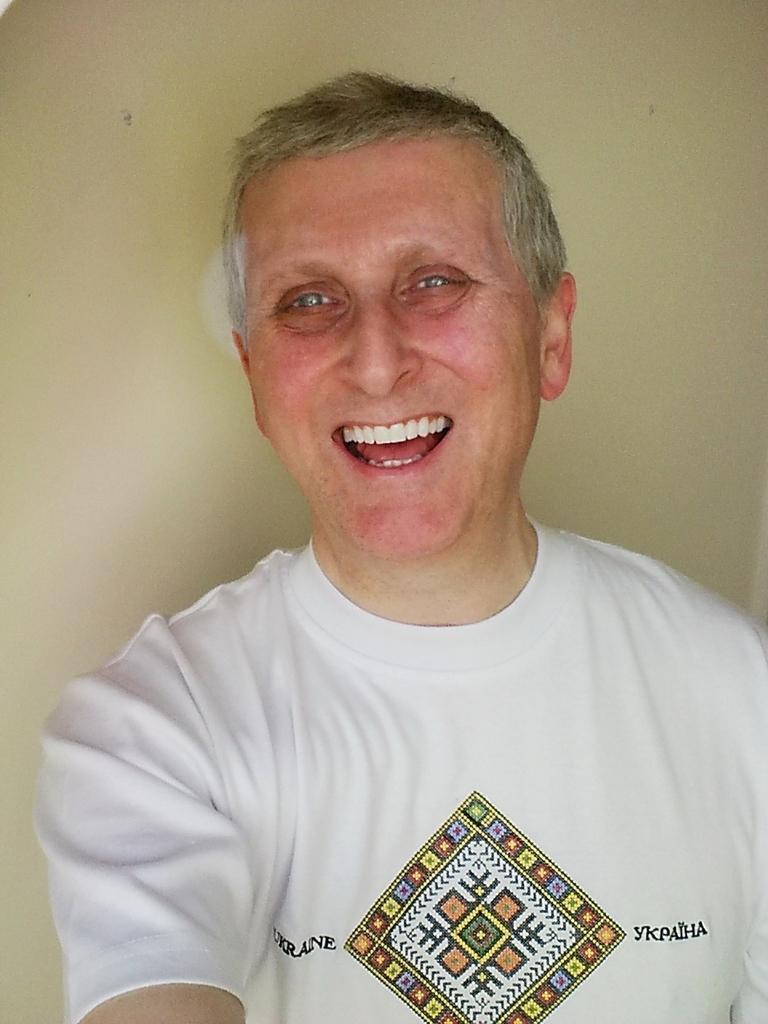Could you give a brief overview of what you see in this image? In the image there is a man with white t-shirt. On the t-shirt there is a design and something written on it. And he is smiling. Behind him there is a wall. 